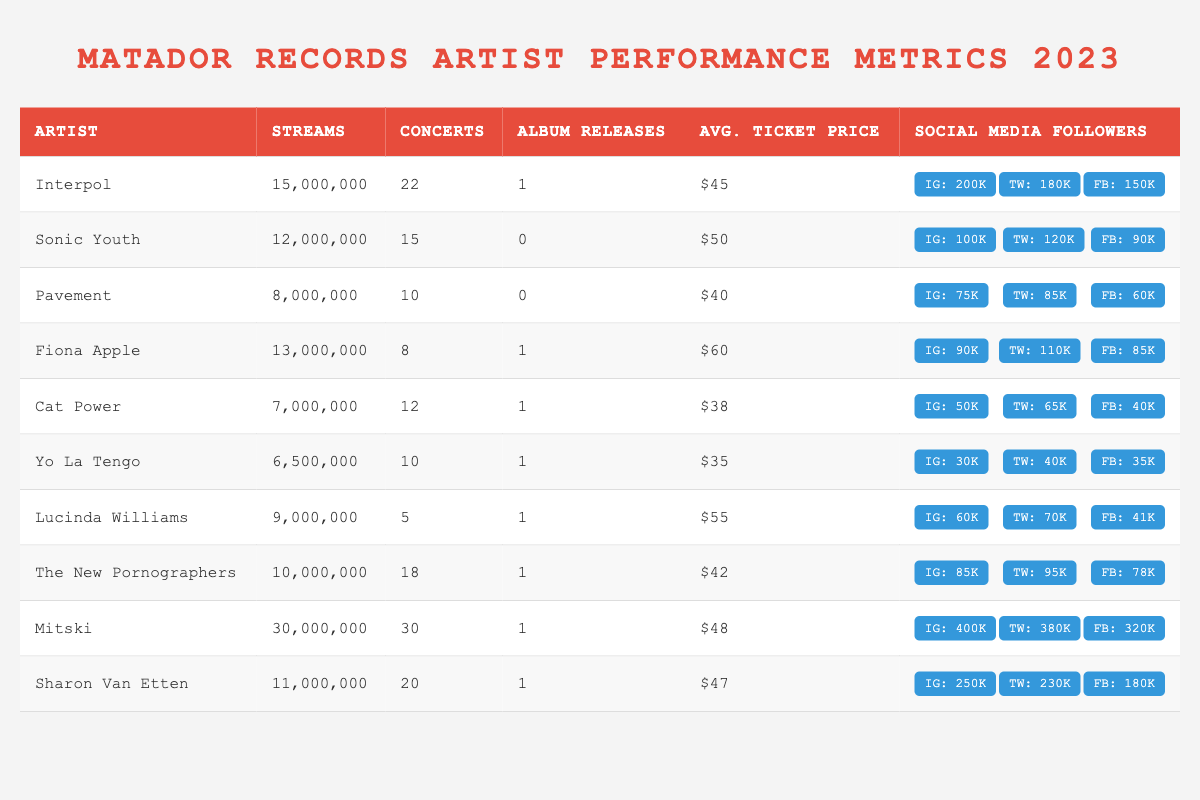What artist has the highest number of streams? By looking at the "Streams" column in the table, Mitski has the highest number with 30,000,000 streams.
Answer: Mitski How many concerts did Sharon Van Etten perform in 2023? The "Concerts" column indicates Sharon Van Etten performed 20 concerts in 2023.
Answer: 20 Which artist released the most albums in 2023? The "Album Releases" column shows that multiple artists released 1 album, so no artist stands out for releasing more than 1 album.
Answer: None (tie) What is the average ticket price for Yo La Tengo's concerts? The "Avg. Ticket Price" column lists Yo La Tengo with an average ticket price of $35.
Answer: $35 How many more streams did Interpol have compared to Pavement? Interpol had 15,000,000 streams, and Pavement had 8,000,000. Thus, 15,000,000 - 8,000,000 = 7,000,000 more streams.
Answer: 7,000,000 What is the total number of concerts performed by all artists listed? Summing the "Concerts" column gives: 22 + 15 + 10 + 8 + 12 + 10 + 5 + 18 + 30 + 20 = 150 total concerts.
Answer: 150 Which artist has the lowest average ticket price? The "Avg. Ticket Price" column shows Cat Power with the lowest average ticket price of $38.
Answer: Cat Power Did Fiona Apple perform more concerts than Sonic Youth? Fiona Apple performed 8 concerts, while Sonic Youth performed 15. Since 8 is less than 15, Fiona Apple performed fewer concerts.
Answer: No What is the total number of social media followers for Mitski across all platforms? Summing Mitski's social media followers: 400,000 (Instagram) + 380,000 (Twitter) + 320,000 (Facebook) = 1,100,000 followers in total.
Answer: 1,100,000 How many more concerts did Mitski perform than Lucinda Williams? Mitski performed 30 concerts, while Lucinda Williams performed 5. Therefore, 30 - 5 = 25 more concerts.
Answer: 25 